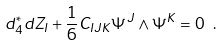Convert formula to latex. <formula><loc_0><loc_0><loc_500><loc_500>d ^ { * } _ { 4 } d Z _ { I } + { \frac { 1 } { 6 } } C _ { I J K } \Psi ^ { J } \wedge \Psi ^ { K } = 0 \ .</formula> 